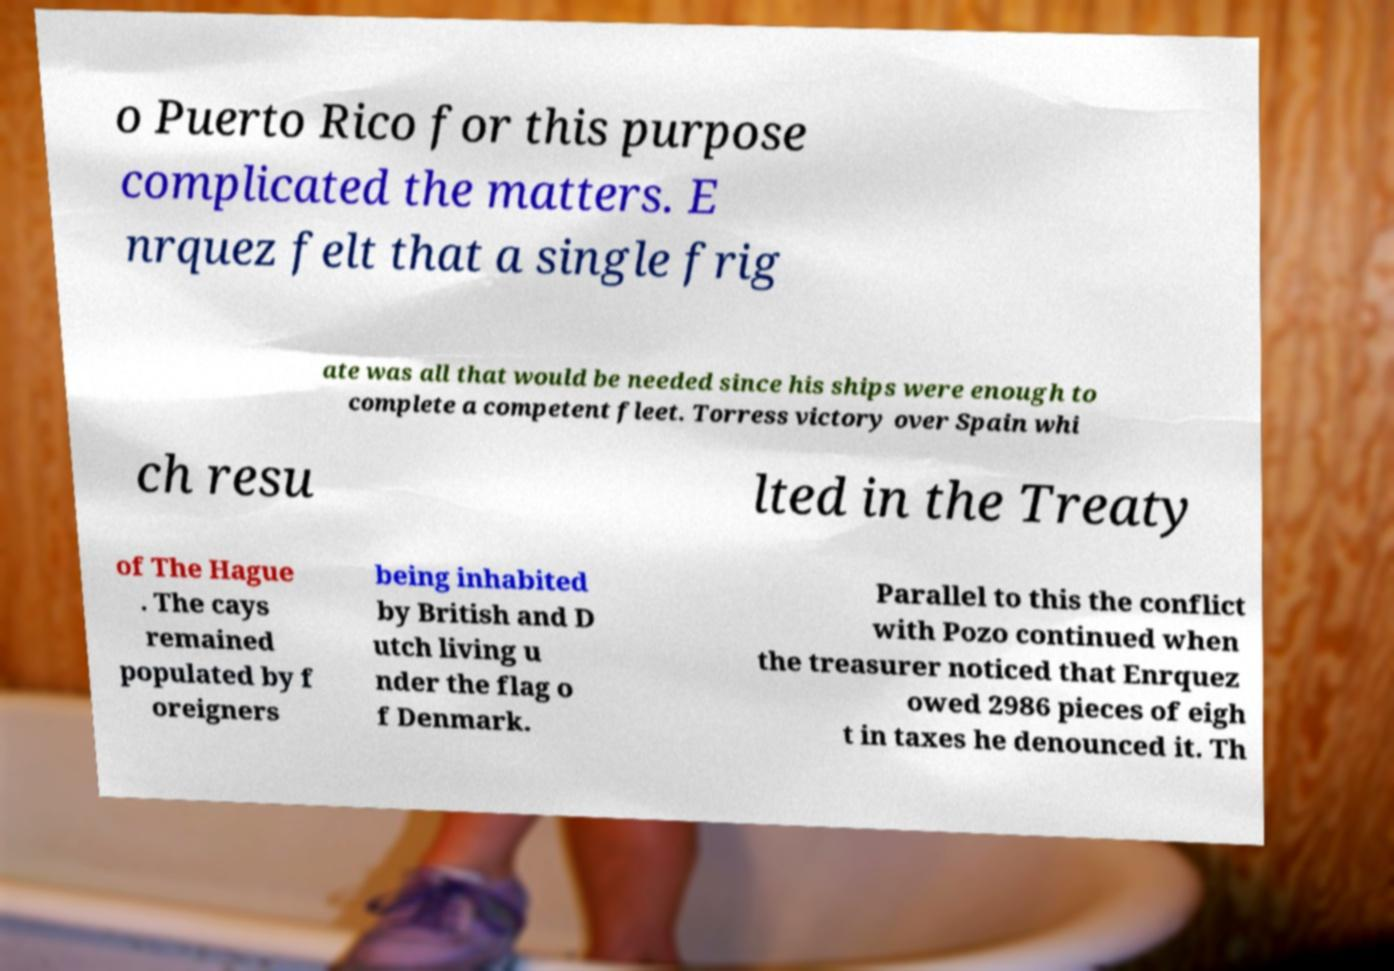Could you assist in decoding the text presented in this image and type it out clearly? o Puerto Rico for this purpose complicated the matters. E nrquez felt that a single frig ate was all that would be needed since his ships were enough to complete a competent fleet. Torress victory over Spain whi ch resu lted in the Treaty of The Hague . The cays remained populated by f oreigners being inhabited by British and D utch living u nder the flag o f Denmark. Parallel to this the conflict with Pozo continued when the treasurer noticed that Enrquez owed 2986 pieces of eigh t in taxes he denounced it. Th 